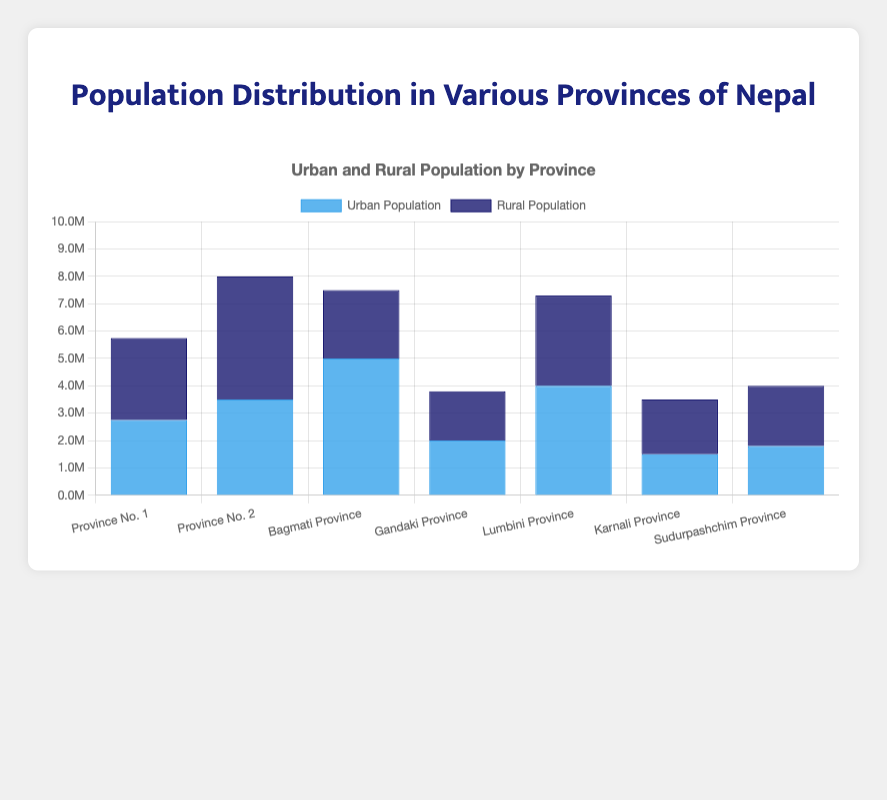What's the total population of Bagmati Province? To find the total population of Bagmati Province, add the urban population (5,000,000) and the rural population (2,500,000). The total population is 5,000,000 + 2,500,000 = 7,500,000.
Answer: 7,500,000 Which province has the highest urban population? Compare the urban populations of all provinces. Bagmati Province has the highest urban population with 5,000,000 people.
Answer: Bagmati Province Which province has the lowest rural population? Compare the rural populations of all provinces. Gandaki Province has the lowest rural population with 1,800,000 people.
Answer: Gandaki Province What's the difference between the urban and rural populations of Province No. 2? Subtract the rural population of Province No. 2 (4,500,000) from its urban population (3,500,000). The difference is 4,500,000 - 3,500,000 = 1,000,000.
Answer: 1,000,000 Which province has a higher total population, Karnali Province or Sudurpashchim Province? Calculate the total populations for both provinces by adding urban and rural populations. Karnali: 1,500,000 + 2,000,000 = 3,500,000. Sudurpashchim: 1,800,000 + 2,200,000 = 4,000,000. Sudurpashchim Province has a higher total population.
Answer: Sudurpashchim Province What's the average urban population across all provinces? Sum the urban populations of all provinces and divide by the number of provinces. (2,750,000 + 3,500,000 + 5,000,000 + 2,000,000 + 4,000,000 + 1,500,000 + 1,800,000) / 7 = 2,935,714.29.
Answer: 2,935,714.29 Which provinces have more rural population than urban population? Compare rural and urban populations for each province. Province No. 1, Province No. 2, Karnali Province, and Sudurpashchim Province have more rural population than urban population.
Answer: Province No. 1, Province No. 2, Karnali Province, Sudurpashchim Province What's the total rural population across all provinces? Sum the rural populations of all provinces. 3,000,000 + 4,500,000 + 2,500,000 + 1,800,000 + 3,300,000 + 2,000,000 + 2,200,000 = 19,300,000.
Answer: 19,300,000 Which provinces have a balanced urban and rural population (difference less than 500,000)? Find provinces where the absolute difference between urban and rural populations is less than 500,000. Province No. 1 and Sudurpashchim Province meet this criterion.
Answer: Province No. 1, Sudurpashchim Province 